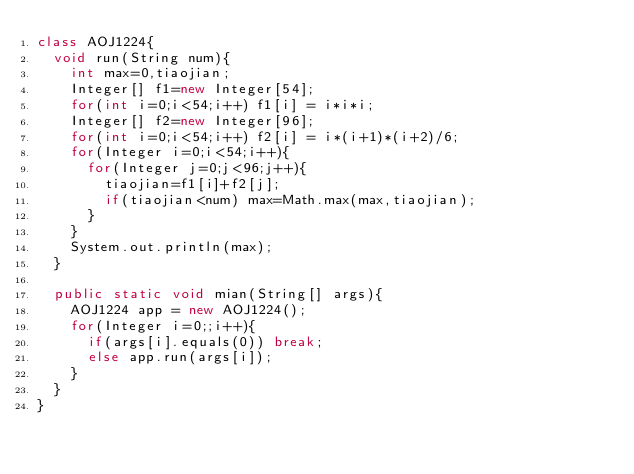<code> <loc_0><loc_0><loc_500><loc_500><_Java_>class AOJ1224{
	void run(String num){
		int max=0,tiaojian;
		Integer[] f1=new Integer[54];
		for(int i=0;i<54;i++) f1[i] = i*i*i;
		Integer[] f2=new Integer[96];
		for(int i=0;i<54;i++) f2[i] = i*(i+1)*(i+2)/6;
		for(Integer i=0;i<54;i++){
			for(Integer j=0;j<96;j++){
				tiaojian=f1[i]+f2[j];
				if(tiaojian<num) max=Math.max(max,tiaojian);
			}
		}
		System.out.println(max);
	}

	public static void mian(String[] args){
		AOJ1224 app = new AOJ1224();
		for(Integer i=0;;i++){
			if(args[i].equals(0)) break;
			else app.run(args[i]);
		}
	}
}
</code> 